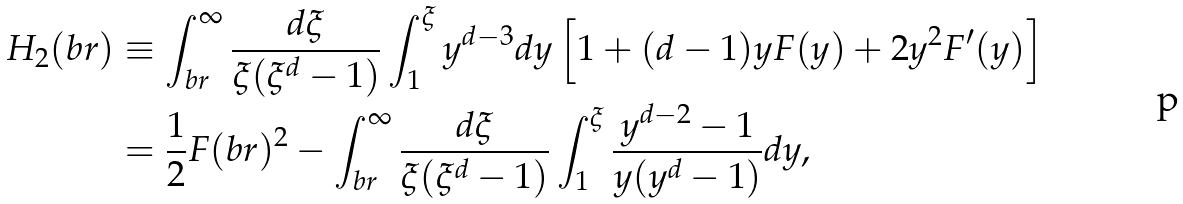Convert formula to latex. <formula><loc_0><loc_0><loc_500><loc_500>H _ { 2 } ( b r ) & \equiv \int _ { b r } ^ { \infty } \frac { d \xi } { \xi ( \xi ^ { d } - 1 ) } \int _ { 1 } ^ { \xi } y ^ { d - 3 } d y \left [ 1 + ( d - 1 ) y F ( y ) + 2 y ^ { 2 } F ^ { \prime } ( y ) \right ] \\ & = \frac { 1 } { 2 } F ( b r ) ^ { 2 } - \int _ { b r } ^ { \infty } \frac { d \xi } { \xi ( \xi ^ { d } - 1 ) } \int _ { 1 } ^ { \xi } \frac { y ^ { d - 2 } - 1 } { y ( y ^ { d } - 1 ) } d y ,</formula> 